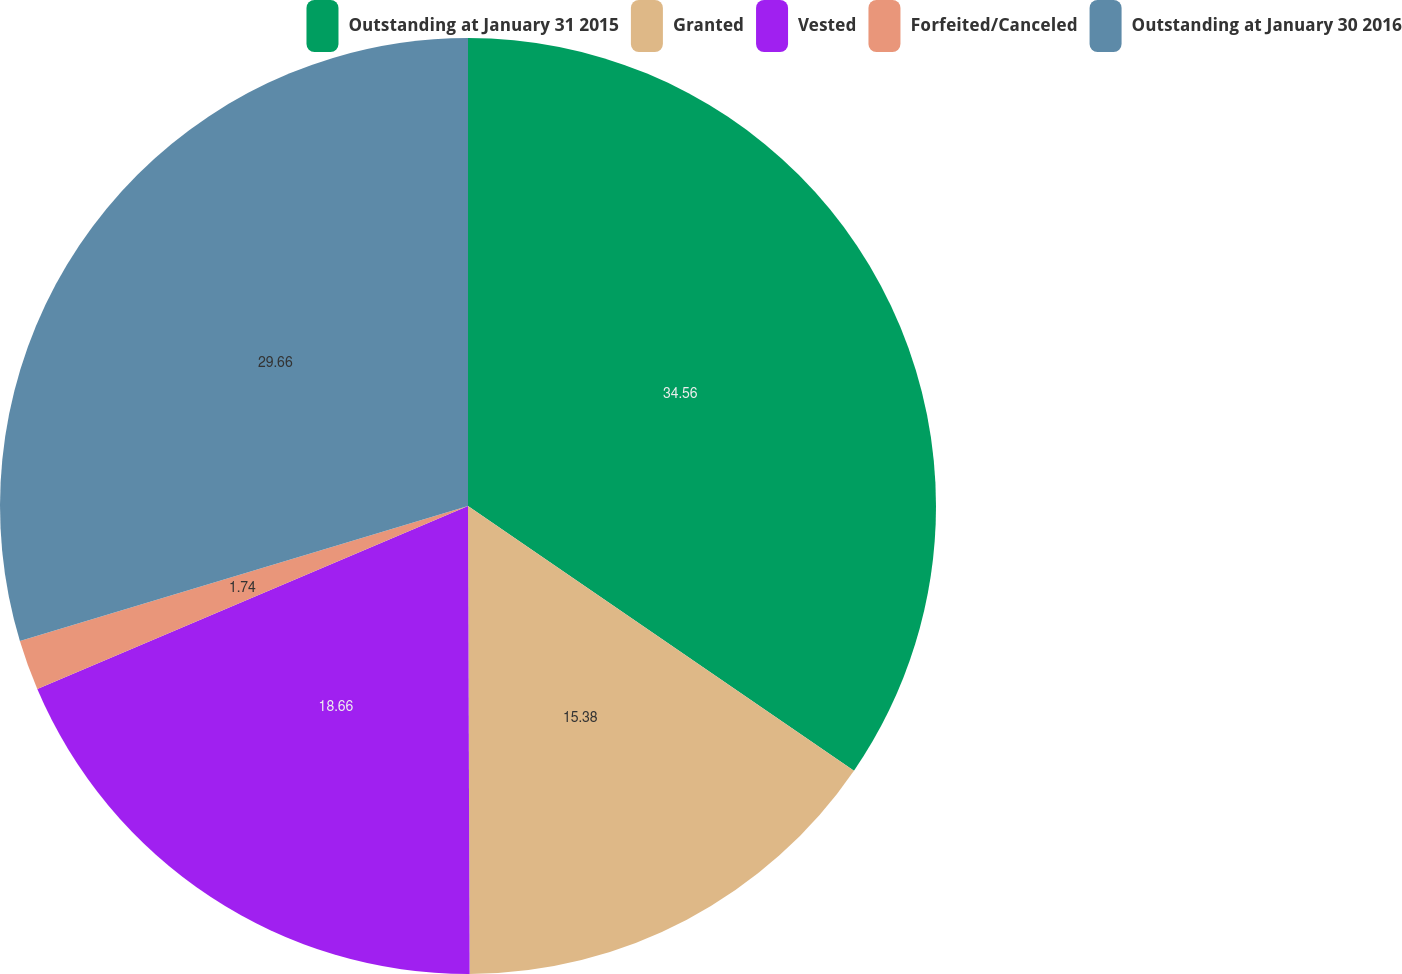Convert chart to OTSL. <chart><loc_0><loc_0><loc_500><loc_500><pie_chart><fcel>Outstanding at January 31 2015<fcel>Granted<fcel>Vested<fcel>Forfeited/Canceled<fcel>Outstanding at January 30 2016<nl><fcel>34.57%<fcel>15.38%<fcel>18.66%<fcel>1.74%<fcel>29.66%<nl></chart> 